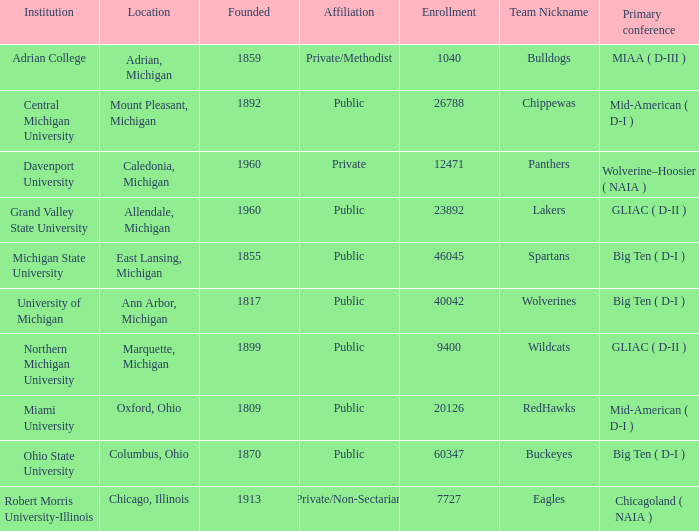I'm looking to parse the entire table for insights. Could you assist me with that? {'header': ['Institution', 'Location', 'Founded', 'Affiliation', 'Enrollment', 'Team Nickname', 'Primary conference'], 'rows': [['Adrian College', 'Adrian, Michigan', '1859', 'Private/Methodist', '1040', 'Bulldogs', 'MIAA ( D-III )'], ['Central Michigan University', 'Mount Pleasant, Michigan', '1892', 'Public', '26788', 'Chippewas', 'Mid-American ( D-I )'], ['Davenport University', 'Caledonia, Michigan', '1960', 'Private', '12471', 'Panthers', 'Wolverine–Hoosier ( NAIA )'], ['Grand Valley State University', 'Allendale, Michigan', '1960', 'Public', '23892', 'Lakers', 'GLIAC ( D-II )'], ['Michigan State University', 'East Lansing, Michigan', '1855', 'Public', '46045', 'Spartans', 'Big Ten ( D-I )'], ['University of Michigan', 'Ann Arbor, Michigan', '1817', 'Public', '40042', 'Wolverines', 'Big Ten ( D-I )'], ['Northern Michigan University', 'Marquette, Michigan', '1899', 'Public', '9400', 'Wildcats', 'GLIAC ( D-II )'], ['Miami University', 'Oxford, Ohio', '1809', 'Public', '20126', 'RedHawks', 'Mid-American ( D-I )'], ['Ohio State University', 'Columbus, Ohio', '1870', 'Public', '60347', 'Buckeyes', 'Big Ten ( D-I )'], ['Robert Morris University-Illinois', 'Chicago, Illinois', '1913', 'Private/Non-Sectarian', '7727', 'Eagles', 'Chicagoland ( NAIA )']]} Where is Robert Morris University-Illinois held? Chicago, Illinois. 